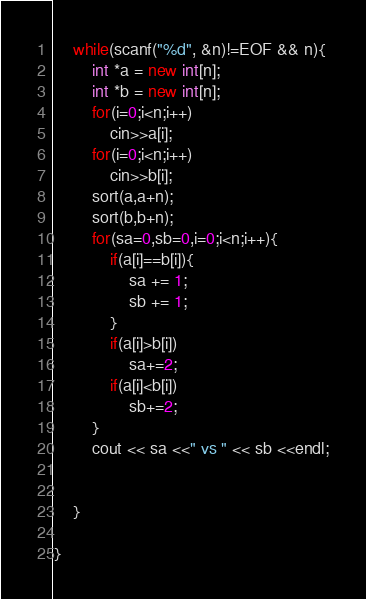Convert code to text. <code><loc_0><loc_0><loc_500><loc_500><_C++_>    while(scanf("%d", &n)!=EOF && n){
        int *a = new int[n];
        int *b = new int[n];
        for(i=0;i<n;i++)
            cin>>a[i];
        for(i=0;i<n;i++)
            cin>>b[i];
        sort(a,a+n);
        sort(b,b+n);
        for(sa=0,sb=0,i=0;i<n;i++){
            if(a[i]==b[i]){
                sa += 1;
                sb += 1;
            }
            if(a[i]>b[i])
                sa+=2;
            if(a[i]<b[i])
                sb+=2;
        }
        cout << sa <<" vs " << sb <<endl;


    }

}

</code> 